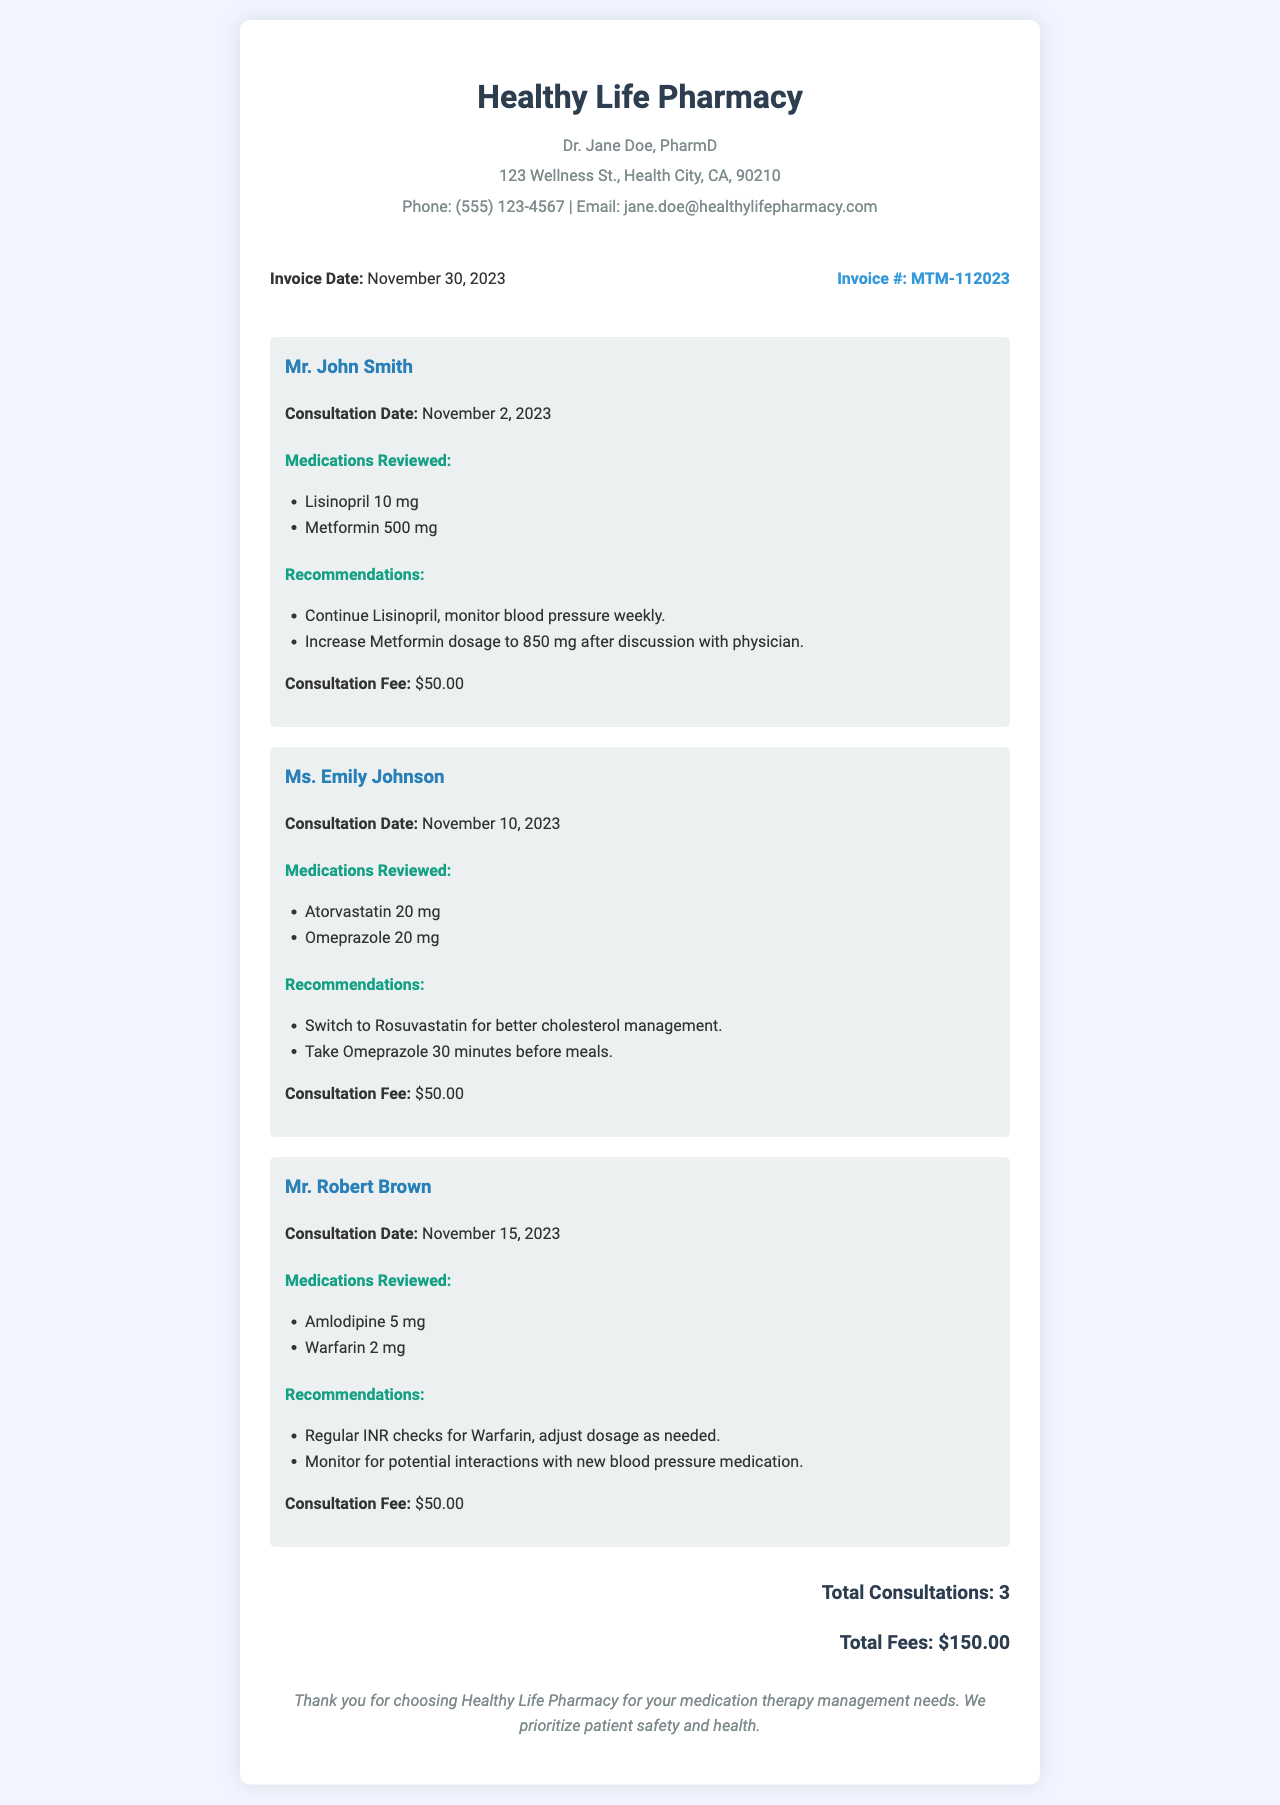What is the invoice number? The invoice number is specifically listed in the document as MTM-112023.
Answer: MTM-112023 Who is the pharmacist associated with this invoice? The pharmacist's name is mentioned in the header of the document as Dr. Jane Doe, PharmD.
Answer: Dr. Jane Doe, PharmD How many patients received consultations in November 2023? The document summarizes the consultations and states that there were a total of 3 patients.
Answer: 3 What is the total fee for consultations provided? The total fee is calculated as the sum of fees from each patient, which totals $150.00.
Answer: $150.00 On what date did Mr. John Smith have his consultation? The consultation date for Mr. John Smith is listed as November 2, 2023.
Answer: November 2, 2023 What recommendation was given to Ms. Emily Johnson regarding her medication? Ms. Emily Johnson was advised to switch to Rosuvastatin for better cholesterol management as per the recommendations noted.
Answer: Switch to Rosuvastatin What medications were reviewed for Mr. Robert Brown? The medications reviewed for Mr. Robert Brown include Amlodipine 5 mg and Warfarin 2 mg as listed in the document.
Answer: Amlodipine 5 mg, Warfarin 2 mg What is the consultation fee per patient? Each patient's consultation fee is clearly stated in the document as $50.00.
Answer: $50.00 What is the consultation date for Ms. Emily Johnson? The document provides that Ms. Emily Johnson had her consultation on November 10, 2023.
Answer: November 10, 2023 